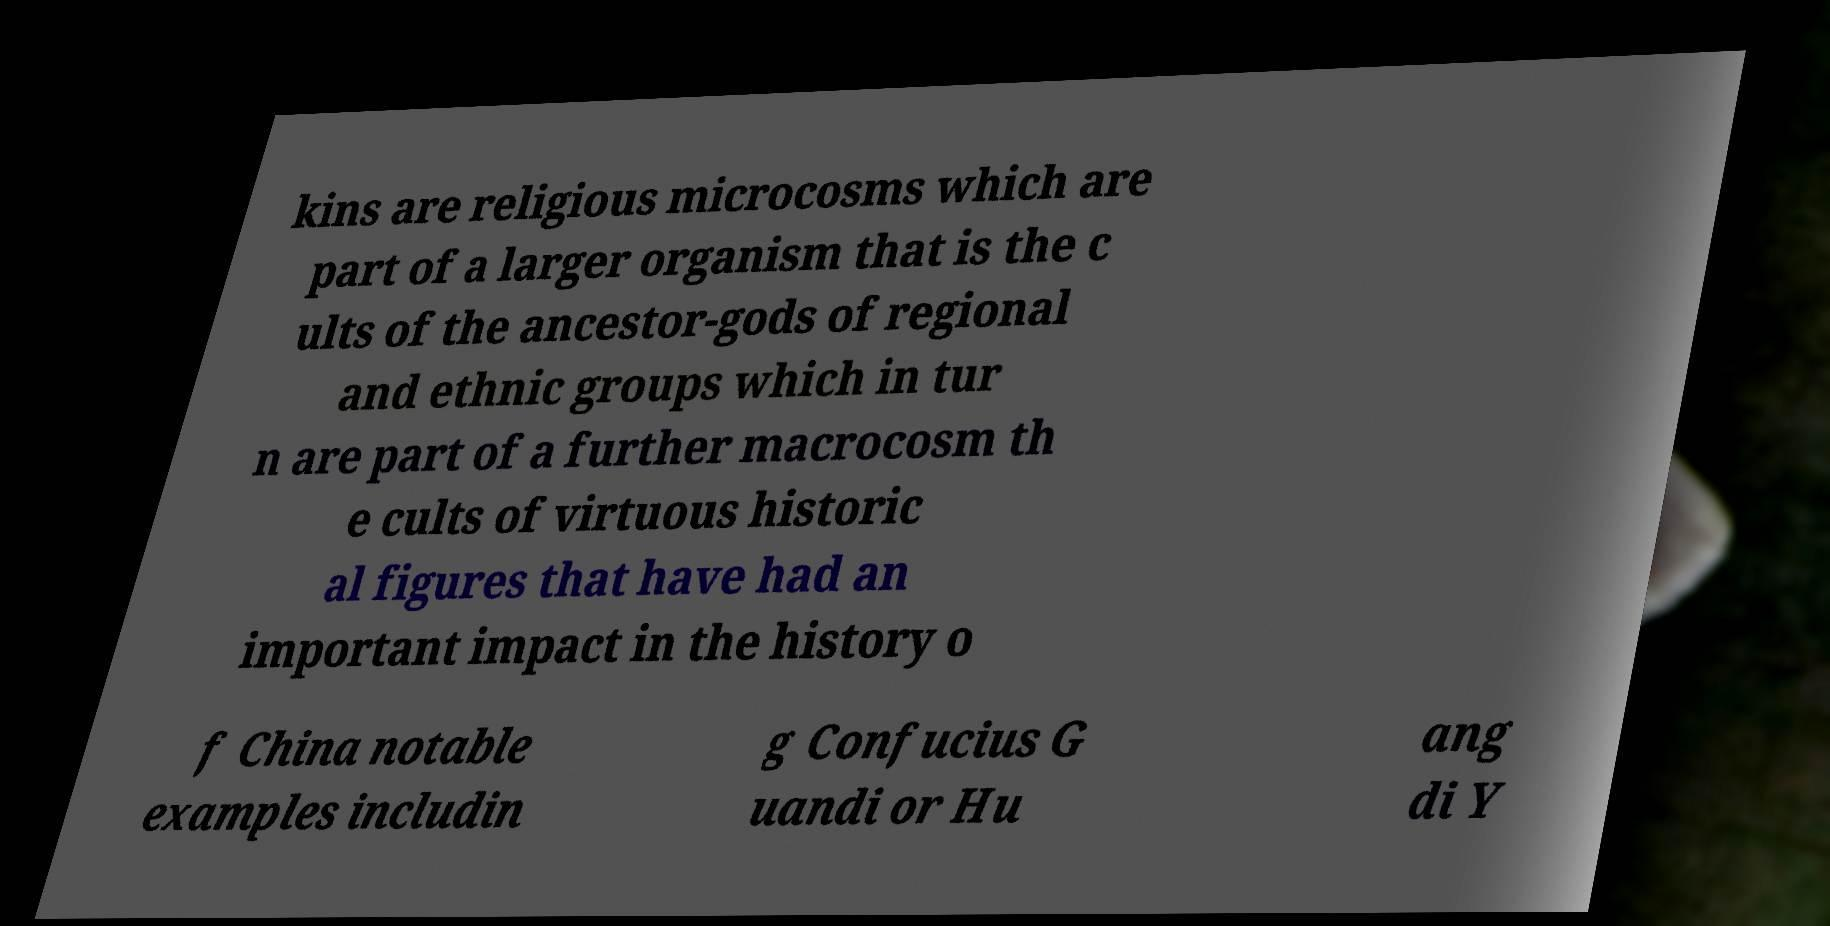Could you assist in decoding the text presented in this image and type it out clearly? kins are religious microcosms which are part of a larger organism that is the c ults of the ancestor-gods of regional and ethnic groups which in tur n are part of a further macrocosm th e cults of virtuous historic al figures that have had an important impact in the history o f China notable examples includin g Confucius G uandi or Hu ang di Y 